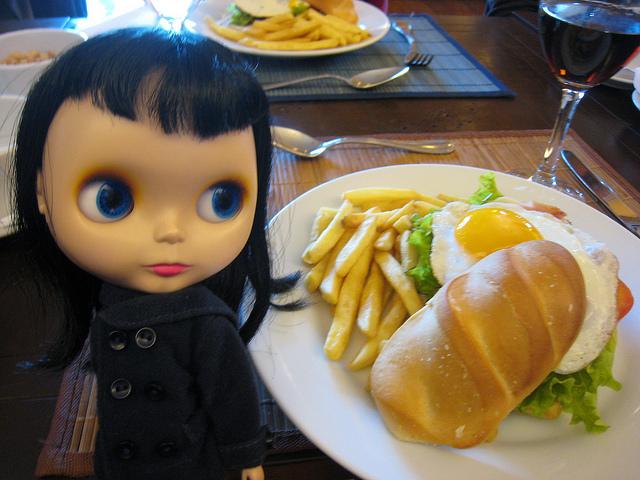Is this sandwich too big to bite through?
Answer briefly. Yes. What is the sandwich wrapped in?
Keep it brief. Bread. What is under the bread?
Concise answer only. Egg. What color are the dolls eyes?
Give a very brief answer. Blue. Where is the doll?
Quick response, please. Table. What color is the plate?
Keep it brief. White. 